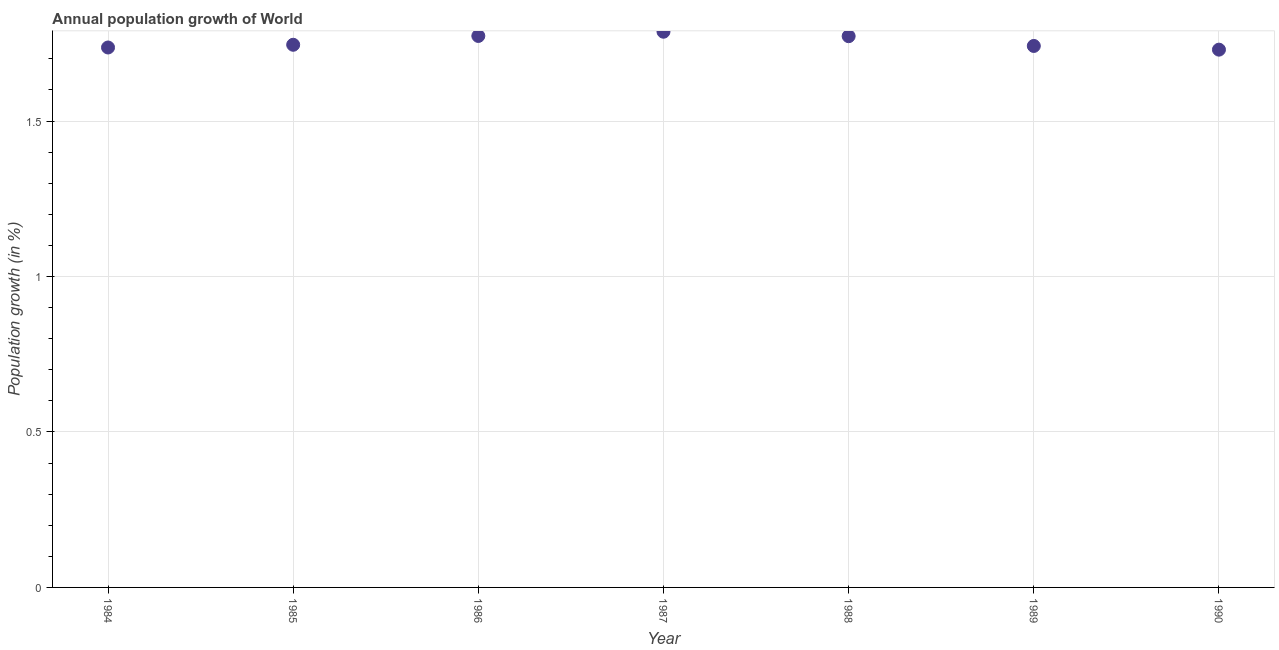What is the population growth in 1986?
Your response must be concise. 1.77. Across all years, what is the maximum population growth?
Provide a short and direct response. 1.79. Across all years, what is the minimum population growth?
Offer a terse response. 1.73. In which year was the population growth maximum?
Your answer should be compact. 1987. What is the sum of the population growth?
Give a very brief answer. 12.29. What is the difference between the population growth in 1988 and 1989?
Offer a very short reply. 0.03. What is the average population growth per year?
Offer a very short reply. 1.76. What is the median population growth?
Ensure brevity in your answer.  1.75. In how many years, is the population growth greater than 1.2 %?
Offer a terse response. 7. Do a majority of the years between 1985 and 1988 (inclusive) have population growth greater than 0.6 %?
Provide a short and direct response. Yes. What is the ratio of the population growth in 1984 to that in 1987?
Offer a terse response. 0.97. Is the difference between the population growth in 1985 and 1989 greater than the difference between any two years?
Keep it short and to the point. No. What is the difference between the highest and the second highest population growth?
Ensure brevity in your answer.  0.01. What is the difference between the highest and the lowest population growth?
Provide a succinct answer. 0.06. In how many years, is the population growth greater than the average population growth taken over all years?
Keep it short and to the point. 3. Does the graph contain any zero values?
Give a very brief answer. No. Does the graph contain grids?
Ensure brevity in your answer.  Yes. What is the title of the graph?
Offer a terse response. Annual population growth of World. What is the label or title of the X-axis?
Offer a very short reply. Year. What is the label or title of the Y-axis?
Your answer should be compact. Population growth (in %). What is the Population growth (in %) in 1984?
Offer a very short reply. 1.74. What is the Population growth (in %) in 1985?
Make the answer very short. 1.75. What is the Population growth (in %) in 1986?
Provide a short and direct response. 1.77. What is the Population growth (in %) in 1987?
Offer a very short reply. 1.79. What is the Population growth (in %) in 1988?
Your answer should be compact. 1.77. What is the Population growth (in %) in 1989?
Make the answer very short. 1.74. What is the Population growth (in %) in 1990?
Your response must be concise. 1.73. What is the difference between the Population growth (in %) in 1984 and 1985?
Provide a succinct answer. -0.01. What is the difference between the Population growth (in %) in 1984 and 1986?
Your answer should be compact. -0.04. What is the difference between the Population growth (in %) in 1984 and 1987?
Provide a short and direct response. -0.05. What is the difference between the Population growth (in %) in 1984 and 1988?
Offer a very short reply. -0.04. What is the difference between the Population growth (in %) in 1984 and 1989?
Your answer should be very brief. -0. What is the difference between the Population growth (in %) in 1984 and 1990?
Offer a terse response. 0.01. What is the difference between the Population growth (in %) in 1985 and 1986?
Provide a succinct answer. -0.03. What is the difference between the Population growth (in %) in 1985 and 1987?
Provide a succinct answer. -0.04. What is the difference between the Population growth (in %) in 1985 and 1988?
Offer a very short reply. -0.03. What is the difference between the Population growth (in %) in 1985 and 1989?
Offer a terse response. 0. What is the difference between the Population growth (in %) in 1985 and 1990?
Provide a short and direct response. 0.02. What is the difference between the Population growth (in %) in 1986 and 1987?
Ensure brevity in your answer.  -0.01. What is the difference between the Population growth (in %) in 1986 and 1988?
Your response must be concise. 0. What is the difference between the Population growth (in %) in 1986 and 1989?
Offer a very short reply. 0.03. What is the difference between the Population growth (in %) in 1986 and 1990?
Keep it short and to the point. 0.04. What is the difference between the Population growth (in %) in 1987 and 1988?
Offer a terse response. 0.01. What is the difference between the Population growth (in %) in 1987 and 1989?
Provide a succinct answer. 0.05. What is the difference between the Population growth (in %) in 1987 and 1990?
Give a very brief answer. 0.06. What is the difference between the Population growth (in %) in 1988 and 1989?
Ensure brevity in your answer.  0.03. What is the difference between the Population growth (in %) in 1988 and 1990?
Your answer should be compact. 0.04. What is the difference between the Population growth (in %) in 1989 and 1990?
Offer a terse response. 0.01. What is the ratio of the Population growth (in %) in 1984 to that in 1985?
Your response must be concise. 0.99. What is the ratio of the Population growth (in %) in 1984 to that in 1986?
Offer a terse response. 0.98. What is the ratio of the Population growth (in %) in 1984 to that in 1988?
Provide a succinct answer. 0.98. What is the ratio of the Population growth (in %) in 1984 to that in 1989?
Provide a succinct answer. 1. What is the ratio of the Population growth (in %) in 1984 to that in 1990?
Your response must be concise. 1. What is the ratio of the Population growth (in %) in 1985 to that in 1986?
Make the answer very short. 0.98. What is the ratio of the Population growth (in %) in 1985 to that in 1987?
Make the answer very short. 0.98. What is the ratio of the Population growth (in %) in 1985 to that in 1990?
Make the answer very short. 1.01. What is the ratio of the Population growth (in %) in 1986 to that in 1987?
Ensure brevity in your answer.  0.99. What is the ratio of the Population growth (in %) in 1986 to that in 1989?
Your answer should be very brief. 1.02. What is the ratio of the Population growth (in %) in 1987 to that in 1988?
Ensure brevity in your answer.  1.01. What is the ratio of the Population growth (in %) in 1987 to that in 1989?
Keep it short and to the point. 1.03. What is the ratio of the Population growth (in %) in 1987 to that in 1990?
Your answer should be compact. 1.03. 